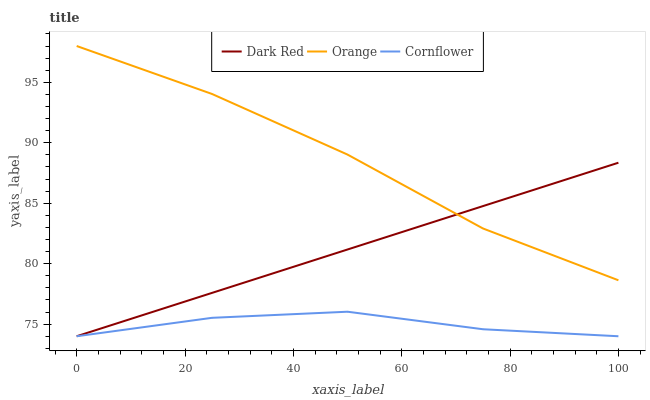Does Cornflower have the minimum area under the curve?
Answer yes or no. Yes. Does Orange have the maximum area under the curve?
Answer yes or no. Yes. Does Dark Red have the minimum area under the curve?
Answer yes or no. No. Does Dark Red have the maximum area under the curve?
Answer yes or no. No. Is Dark Red the smoothest?
Answer yes or no. Yes. Is Orange the roughest?
Answer yes or no. Yes. Is Cornflower the smoothest?
Answer yes or no. No. Is Cornflower the roughest?
Answer yes or no. No. Does Dark Red have the lowest value?
Answer yes or no. Yes. Does Orange have the highest value?
Answer yes or no. Yes. Does Dark Red have the highest value?
Answer yes or no. No. Is Cornflower less than Orange?
Answer yes or no. Yes. Is Orange greater than Cornflower?
Answer yes or no. Yes. Does Dark Red intersect Orange?
Answer yes or no. Yes. Is Dark Red less than Orange?
Answer yes or no. No. Is Dark Red greater than Orange?
Answer yes or no. No. Does Cornflower intersect Orange?
Answer yes or no. No. 